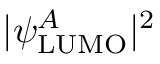Convert formula to latex. <formula><loc_0><loc_0><loc_500><loc_500>| \psi _ { L U M O } ^ { A } | ^ { 2 }</formula> 